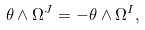<formula> <loc_0><loc_0><loc_500><loc_500>\theta \wedge \Omega ^ { J } = - \theta \wedge \Omega ^ { I } ,</formula> 